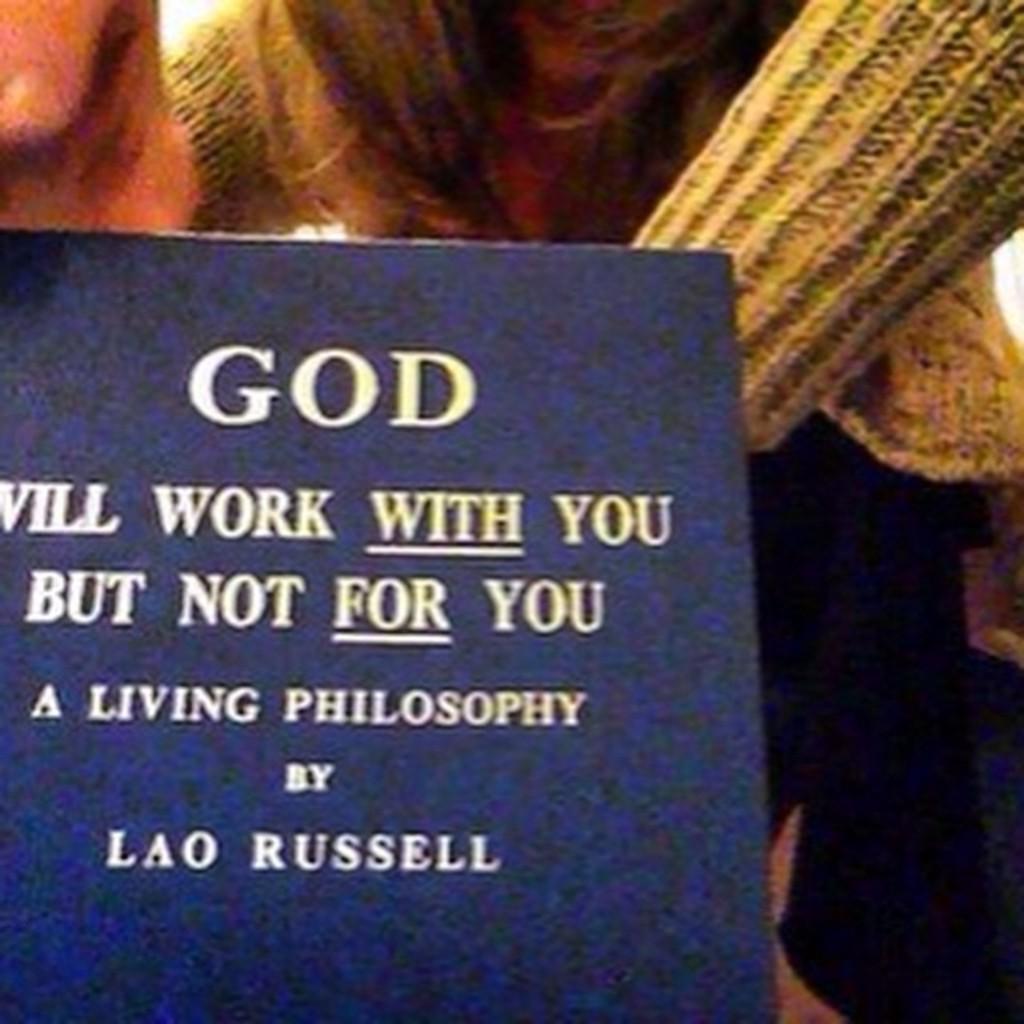Describe this image in one or two sentences. At the left corner of the image there is a book with something written on it. Behind the book there is a person with jacket. 